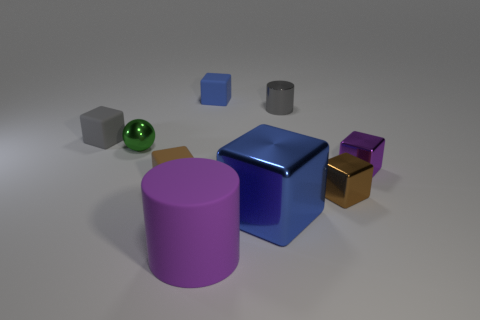How many objects are either blue shiny cubes or cyan shiny cubes?
Your answer should be compact. 1. What is the shape of the large metal thing?
Give a very brief answer. Cube. The small brown thing that is behind the brown block on the right side of the large purple rubber cylinder is what shape?
Your answer should be compact. Cube. Is the small gray thing to the right of the big metal block made of the same material as the small purple thing?
Provide a short and direct response. Yes. How many red things are either big rubber objects or metal balls?
Provide a short and direct response. 0. Is there a matte thing that has the same color as the large metallic block?
Make the answer very short. Yes. Are there any brown things made of the same material as the tiny purple block?
Your answer should be very brief. Yes. What shape is the shiny object that is both to the left of the gray shiny object and on the right side of the tiny blue object?
Your answer should be very brief. Cube. How many big things are either brown shiny spheres or gray shiny cylinders?
Provide a short and direct response. 0. What is the material of the tiny gray cylinder?
Your answer should be very brief. Metal. 